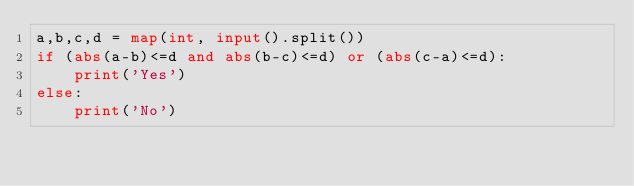<code> <loc_0><loc_0><loc_500><loc_500><_Python_>a,b,c,d = map(int, input().split())
if (abs(a-b)<=d and abs(b-c)<=d) or (abs(c-a)<=d):
    print('Yes')
else:
    print('No')</code> 